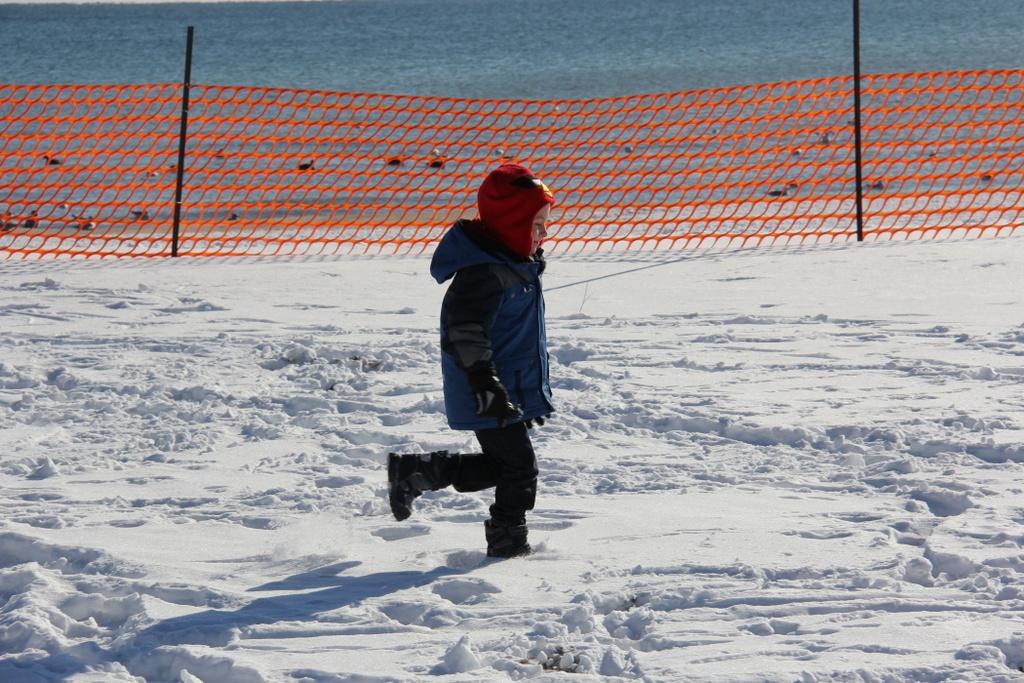What is the main subject of the image? The main subject of the image is a kid. What is the kid doing in the image? The kid is walking on the snow in the image. What can be seen in the background of the image? There are poles with a net in the image, and there appears to be water behind the poles. What type of light can be seen reflecting off the kettle in the image? There is no kettle present in the image, so there is no light reflecting off it. 